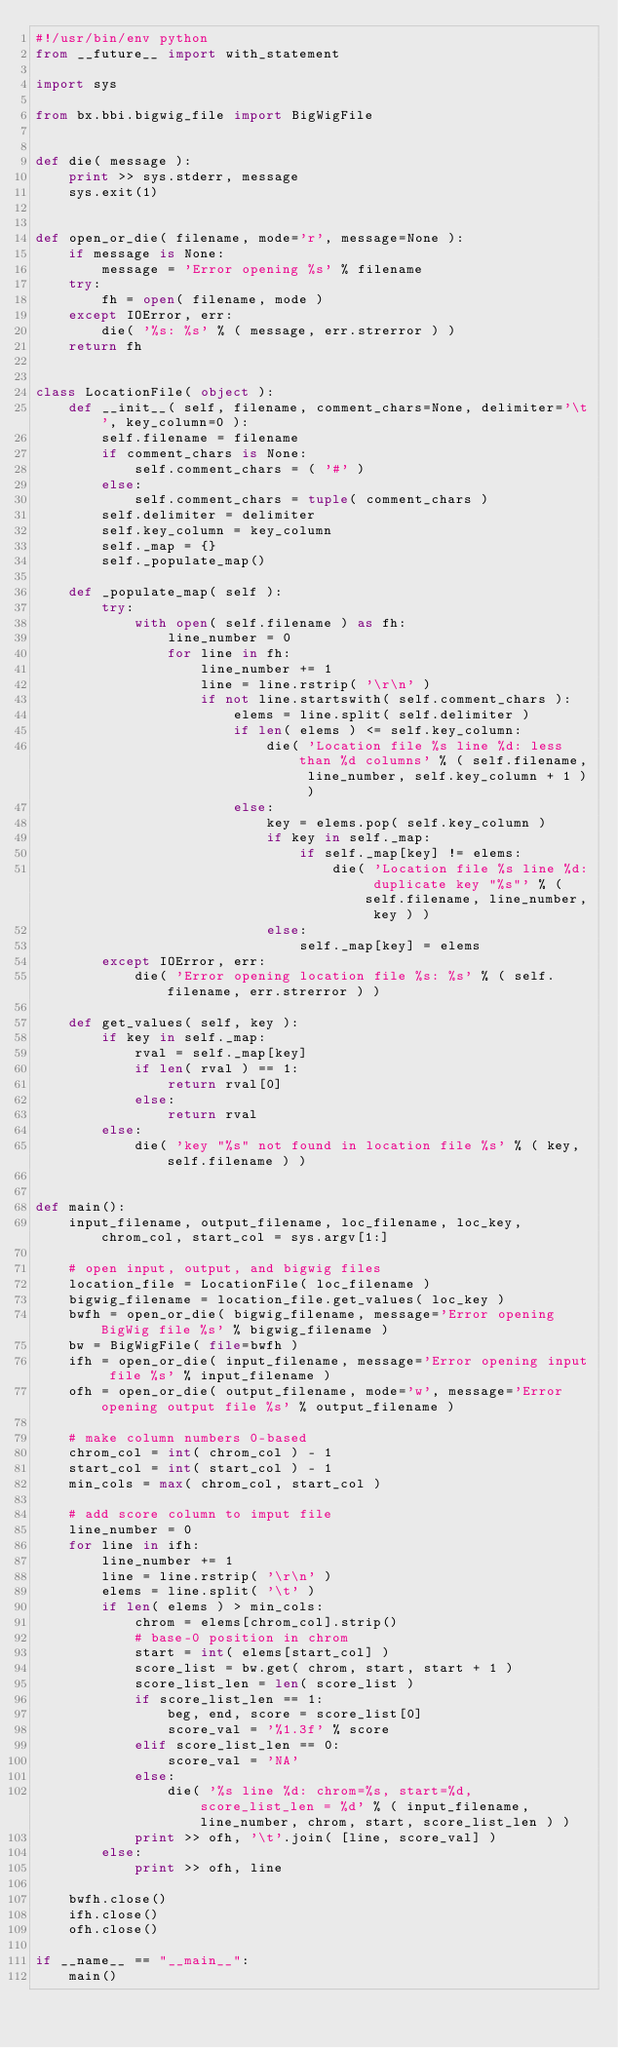<code> <loc_0><loc_0><loc_500><loc_500><_Python_>#!/usr/bin/env python
from __future__ import with_statement

import sys

from bx.bbi.bigwig_file import BigWigFile


def die( message ):
    print >> sys.stderr, message
    sys.exit(1)


def open_or_die( filename, mode='r', message=None ):
    if message is None:
        message = 'Error opening %s' % filename
    try:
        fh = open( filename, mode )
    except IOError, err:
        die( '%s: %s' % ( message, err.strerror ) )
    return fh


class LocationFile( object ):
    def __init__( self, filename, comment_chars=None, delimiter='\t', key_column=0 ):
        self.filename = filename
        if comment_chars is None:
            self.comment_chars = ( '#' )
        else:
            self.comment_chars = tuple( comment_chars )
        self.delimiter = delimiter
        self.key_column = key_column
        self._map = {}
        self._populate_map()

    def _populate_map( self ):
        try:
            with open( self.filename ) as fh:
                line_number = 0
                for line in fh:
                    line_number += 1
                    line = line.rstrip( '\r\n' )
                    if not line.startswith( self.comment_chars ):
                        elems = line.split( self.delimiter )
                        if len( elems ) <= self.key_column:
                            die( 'Location file %s line %d: less than %d columns' % ( self.filename, line_number, self.key_column + 1 ) )
                        else:
                            key = elems.pop( self.key_column )
                            if key in self._map:
                                if self._map[key] != elems:
                                    die( 'Location file %s line %d: duplicate key "%s"' % ( self.filename, line_number, key ) )
                            else:
                                self._map[key] = elems
        except IOError, err:
            die( 'Error opening location file %s: %s' % ( self.filename, err.strerror ) )

    def get_values( self, key ):
        if key in self._map:
            rval = self._map[key]
            if len( rval ) == 1:
                return rval[0]
            else:
                return rval
        else:
            die( 'key "%s" not found in location file %s' % ( key, self.filename ) )


def main():
    input_filename, output_filename, loc_filename, loc_key, chrom_col, start_col = sys.argv[1:]

    # open input, output, and bigwig files
    location_file = LocationFile( loc_filename )
    bigwig_filename = location_file.get_values( loc_key )
    bwfh = open_or_die( bigwig_filename, message='Error opening BigWig file %s' % bigwig_filename )
    bw = BigWigFile( file=bwfh )
    ifh = open_or_die( input_filename, message='Error opening input file %s' % input_filename )
    ofh = open_or_die( output_filename, mode='w', message='Error opening output file %s' % output_filename )

    # make column numbers 0-based
    chrom_col = int( chrom_col ) - 1
    start_col = int( start_col ) - 1
    min_cols = max( chrom_col, start_col )

    # add score column to imput file
    line_number = 0
    for line in ifh:
        line_number += 1
        line = line.rstrip( '\r\n' )
        elems = line.split( '\t' )
        if len( elems ) > min_cols:
            chrom = elems[chrom_col].strip()
            # base-0 position in chrom
            start = int( elems[start_col] )
            score_list = bw.get( chrom, start, start + 1 )
            score_list_len = len( score_list )
            if score_list_len == 1:
                beg, end, score = score_list[0]
                score_val = '%1.3f' % score
            elif score_list_len == 0:
                score_val = 'NA'
            else:
                die( '%s line %d: chrom=%s, start=%d, score_list_len = %d' % ( input_filename, line_number, chrom, start, score_list_len ) )
            print >> ofh, '\t'.join( [line, score_val] )
        else:
            print >> ofh, line

    bwfh.close()
    ifh.close()
    ofh.close()

if __name__ == "__main__":
    main()
</code> 